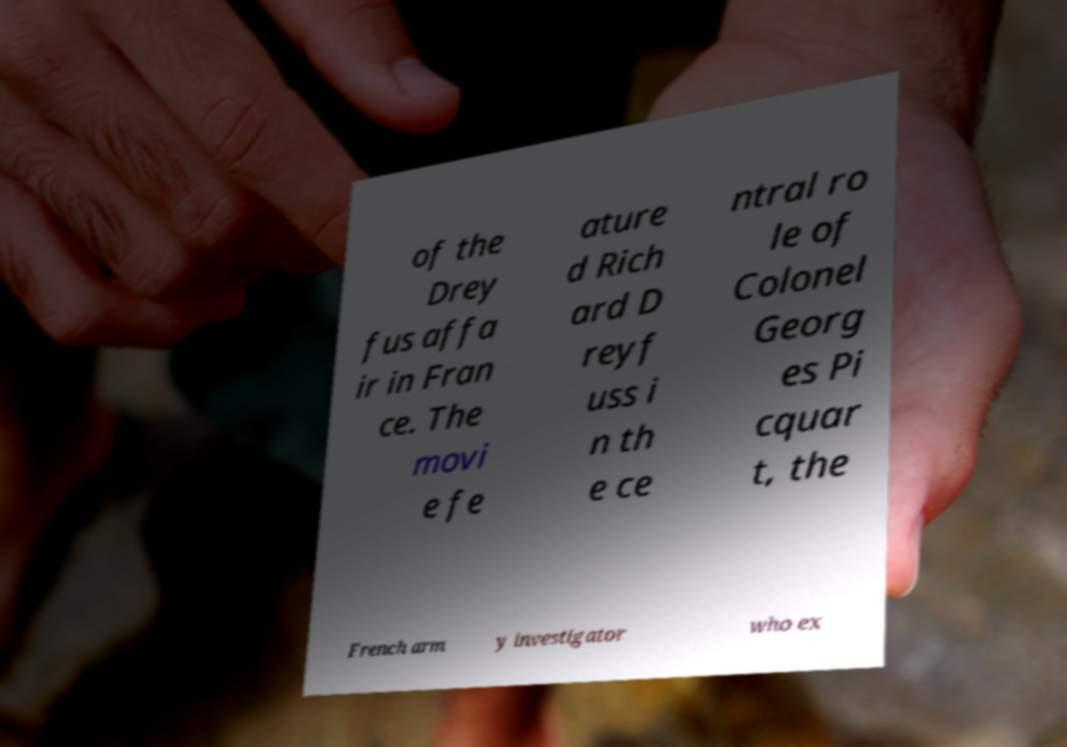Can you accurately transcribe the text from the provided image for me? of the Drey fus affa ir in Fran ce. The movi e fe ature d Rich ard D reyf uss i n th e ce ntral ro le of Colonel Georg es Pi cquar t, the French arm y investigator who ex 